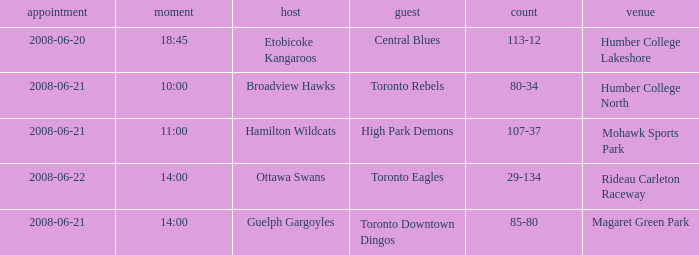What is the Away with a Ground that is humber college north? Toronto Rebels. Could you help me parse every detail presented in this table? {'header': ['appointment', 'moment', 'host', 'guest', 'count', 'venue'], 'rows': [['2008-06-20', '18:45', 'Etobicoke Kangaroos', 'Central Blues', '113-12', 'Humber College Lakeshore'], ['2008-06-21', '10:00', 'Broadview Hawks', 'Toronto Rebels', '80-34', 'Humber College North'], ['2008-06-21', '11:00', 'Hamilton Wildcats', 'High Park Demons', '107-37', 'Mohawk Sports Park'], ['2008-06-22', '14:00', 'Ottawa Swans', 'Toronto Eagles', '29-134', 'Rideau Carleton Raceway'], ['2008-06-21', '14:00', 'Guelph Gargoyles', 'Toronto Downtown Dingos', '85-80', 'Magaret Green Park']]} 